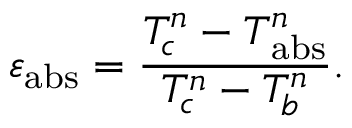Convert formula to latex. <formula><loc_0><loc_0><loc_500><loc_500>\varepsilon _ { a b s } = \frac { T _ { c } ^ { n } - T _ { a b s } ^ { n } } { T _ { c } ^ { n } - T _ { b } ^ { n } } .</formula> 